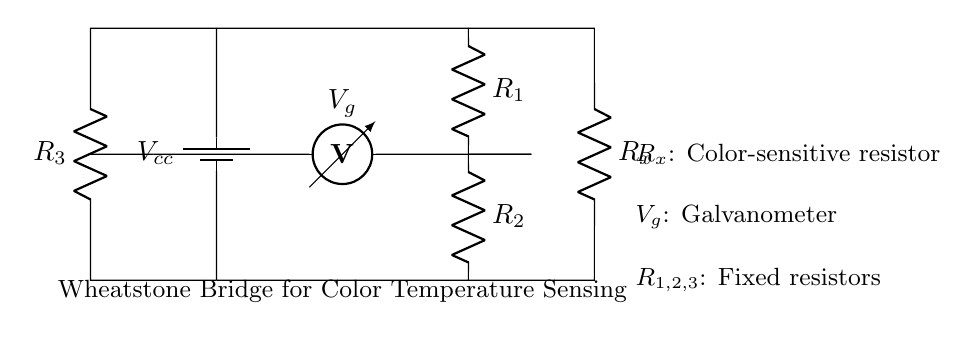What is the source voltage in this circuit? The source voltage, labeled as $V_{cc}$, is the voltage provided by the battery in the circuit. It is represented at the top of the circuit diagram.
Answer: Vcc What type of circuit is this? This is a Wheatstone bridge circuit, which is specifically designed for measuring unknown resistances. The arrangement of resistors in a bridge format and the presence of a galvanometer indicate this type.
Answer: Wheatstone bridge How many fixed resistors are there in the circuit? There are three fixed resistors indicated in the circuit diagram, labeled as $R_1$, $R_2$, and $R_3$. Each is connected in a manner typical of a Wheatstone bridge.
Answer: Three What is connected to the galvanometer in this Wheatstone bridge? The galvanometer, labeled as $V_g$, is connected between the two junctions formed by the resistors $R_1$, $R_2$, $R_3$, and the color-sensitive resistor $R_x$. This connection indicates that it measures the potential difference across the bridge.
Answer: R1, R2, R3, Rx What role does the resistor labeled R_x play? The resistor $R_x$ is a color-sensitive resistor that varies based on the color temperature being sensed. Its resistance changes according to the color of the light, impacting the balance of the bridge and affecting the galvanometer reading.
Answer: Color-sensitive resistor What happens if the bridge is balanced? If the Wheatstone bridge is balanced, the voltage across the galvanometer (V_g) will be zero, indicating that the ratio of the resistances $R_1/R_2$ equals the ratio of $R_3/R_x$, signifying that the unknown resistance can be accurately measured without interference.
Answer: Voltage across galvanometer is zero What is the purpose of the Wheatstone bridge in this context? The purpose of the Wheatstone bridge in this digital art tool context is to allow for precise color temperature sensing by accurately measuring resistance changes in response to varying light conditions, aiding artists in achieving desired color aesthetics.
Answer: Precise color temperature sensing 